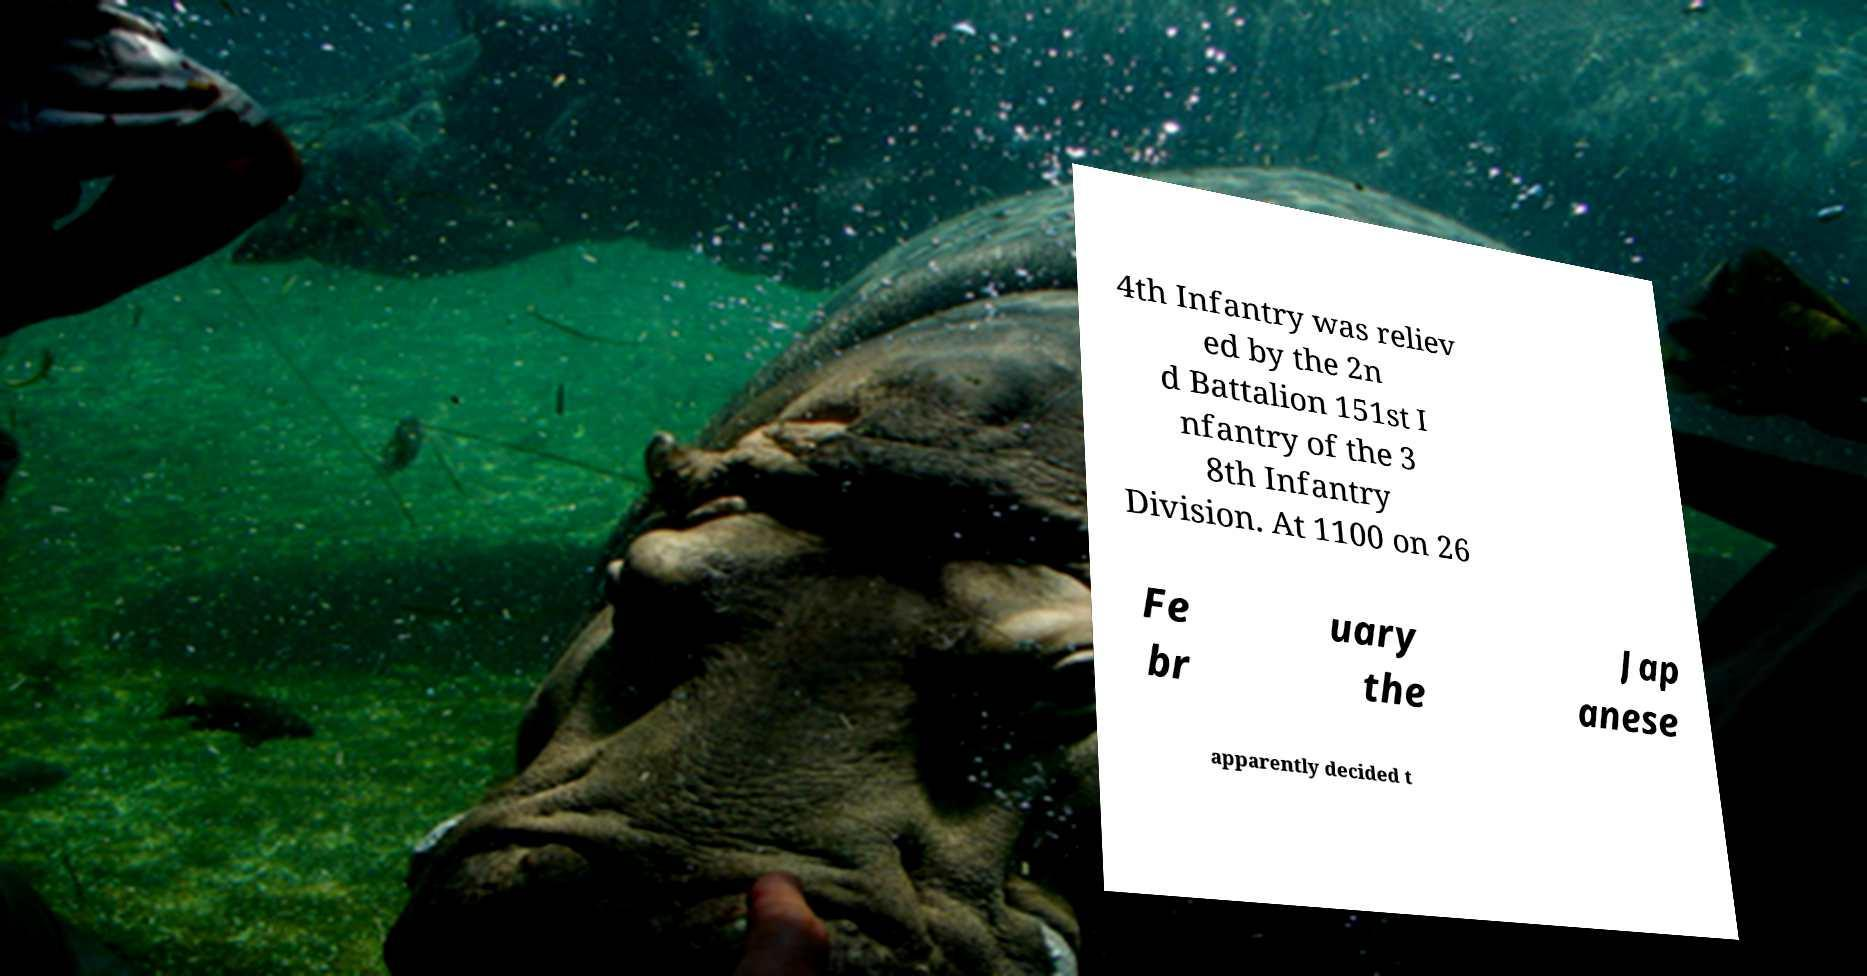There's text embedded in this image that I need extracted. Can you transcribe it verbatim? 4th Infantry was reliev ed by the 2n d Battalion 151st I nfantry of the 3 8th Infantry Division. At 1100 on 26 Fe br uary the Jap anese apparently decided t 